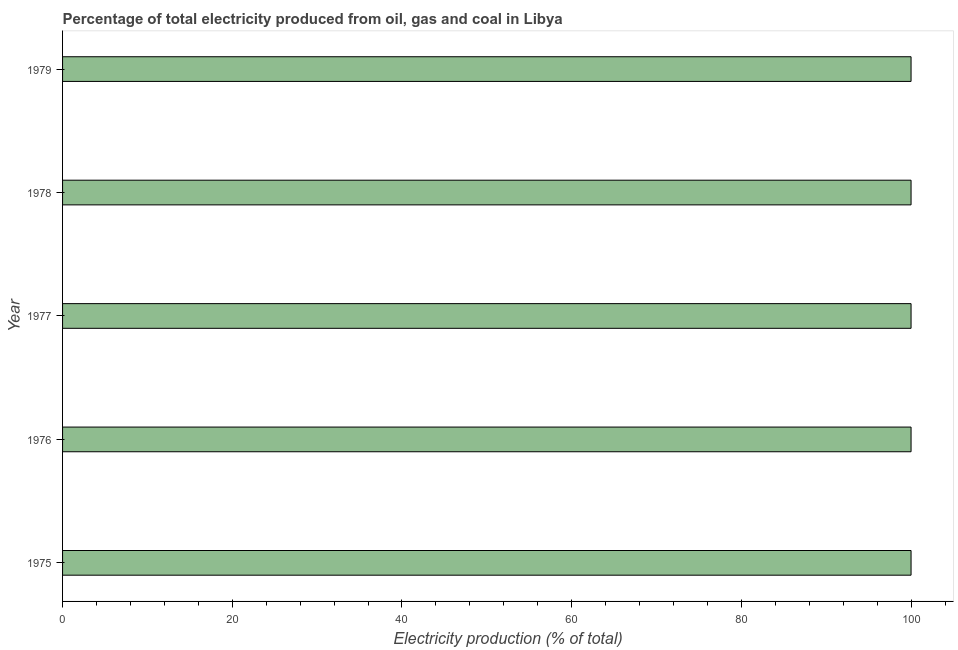What is the title of the graph?
Give a very brief answer. Percentage of total electricity produced from oil, gas and coal in Libya. What is the label or title of the X-axis?
Make the answer very short. Electricity production (% of total). Across all years, what is the maximum electricity production?
Ensure brevity in your answer.  100. Across all years, what is the minimum electricity production?
Your answer should be compact. 100. In which year was the electricity production maximum?
Give a very brief answer. 1975. In which year was the electricity production minimum?
Make the answer very short. 1975. What is the sum of the electricity production?
Offer a very short reply. 500. What is the difference between the electricity production in 1977 and 1978?
Provide a short and direct response. 0. What is the median electricity production?
Your answer should be very brief. 100. Is the electricity production in 1975 less than that in 1978?
Give a very brief answer. No. Is the difference between the electricity production in 1975 and 1978 greater than the difference between any two years?
Give a very brief answer. Yes. What is the difference between the highest and the second highest electricity production?
Keep it short and to the point. 0. Are all the bars in the graph horizontal?
Your answer should be very brief. Yes. How many years are there in the graph?
Give a very brief answer. 5. Are the values on the major ticks of X-axis written in scientific E-notation?
Your answer should be very brief. No. What is the Electricity production (% of total) of 1976?
Ensure brevity in your answer.  100. What is the Electricity production (% of total) in 1978?
Your answer should be very brief. 100. What is the Electricity production (% of total) of 1979?
Provide a succinct answer. 100. What is the difference between the Electricity production (% of total) in 1975 and 1978?
Give a very brief answer. 0. What is the difference between the Electricity production (% of total) in 1976 and 1978?
Keep it short and to the point. 0. What is the difference between the Electricity production (% of total) in 1978 and 1979?
Make the answer very short. 0. What is the ratio of the Electricity production (% of total) in 1975 to that in 1979?
Make the answer very short. 1. What is the ratio of the Electricity production (% of total) in 1976 to that in 1979?
Provide a short and direct response. 1. What is the ratio of the Electricity production (% of total) in 1977 to that in 1978?
Your answer should be compact. 1. What is the ratio of the Electricity production (% of total) in 1977 to that in 1979?
Ensure brevity in your answer.  1. What is the ratio of the Electricity production (% of total) in 1978 to that in 1979?
Provide a succinct answer. 1. 